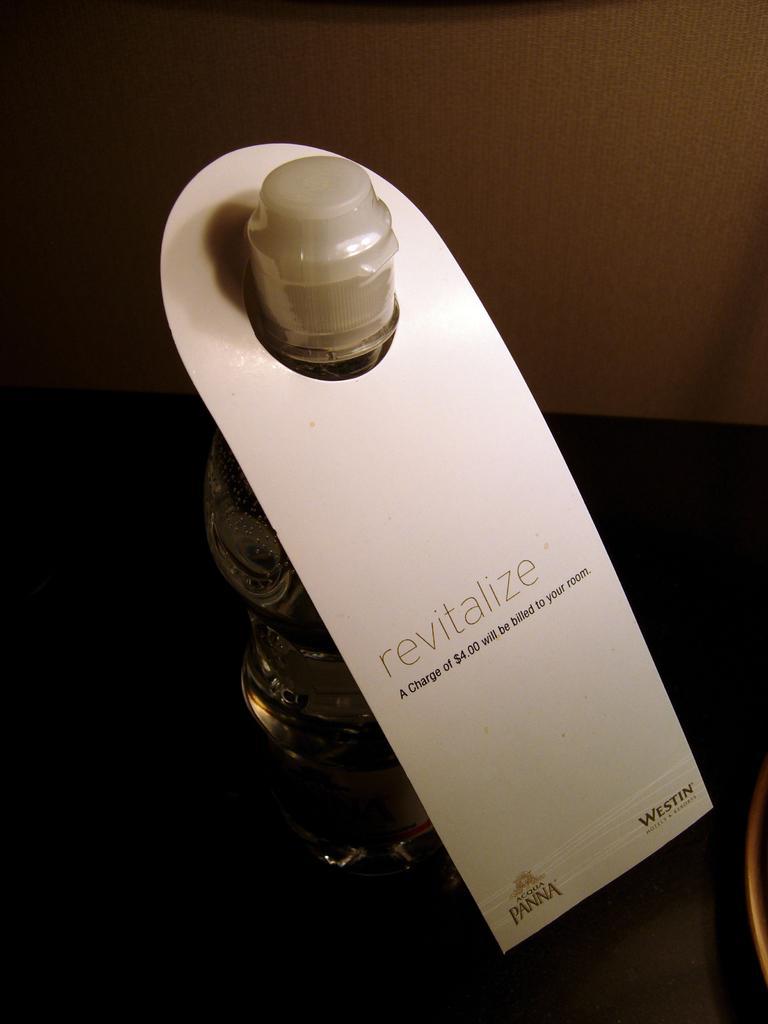Please provide a concise description of this image. In this picture there is a glass bottle which is named as revitalize. 